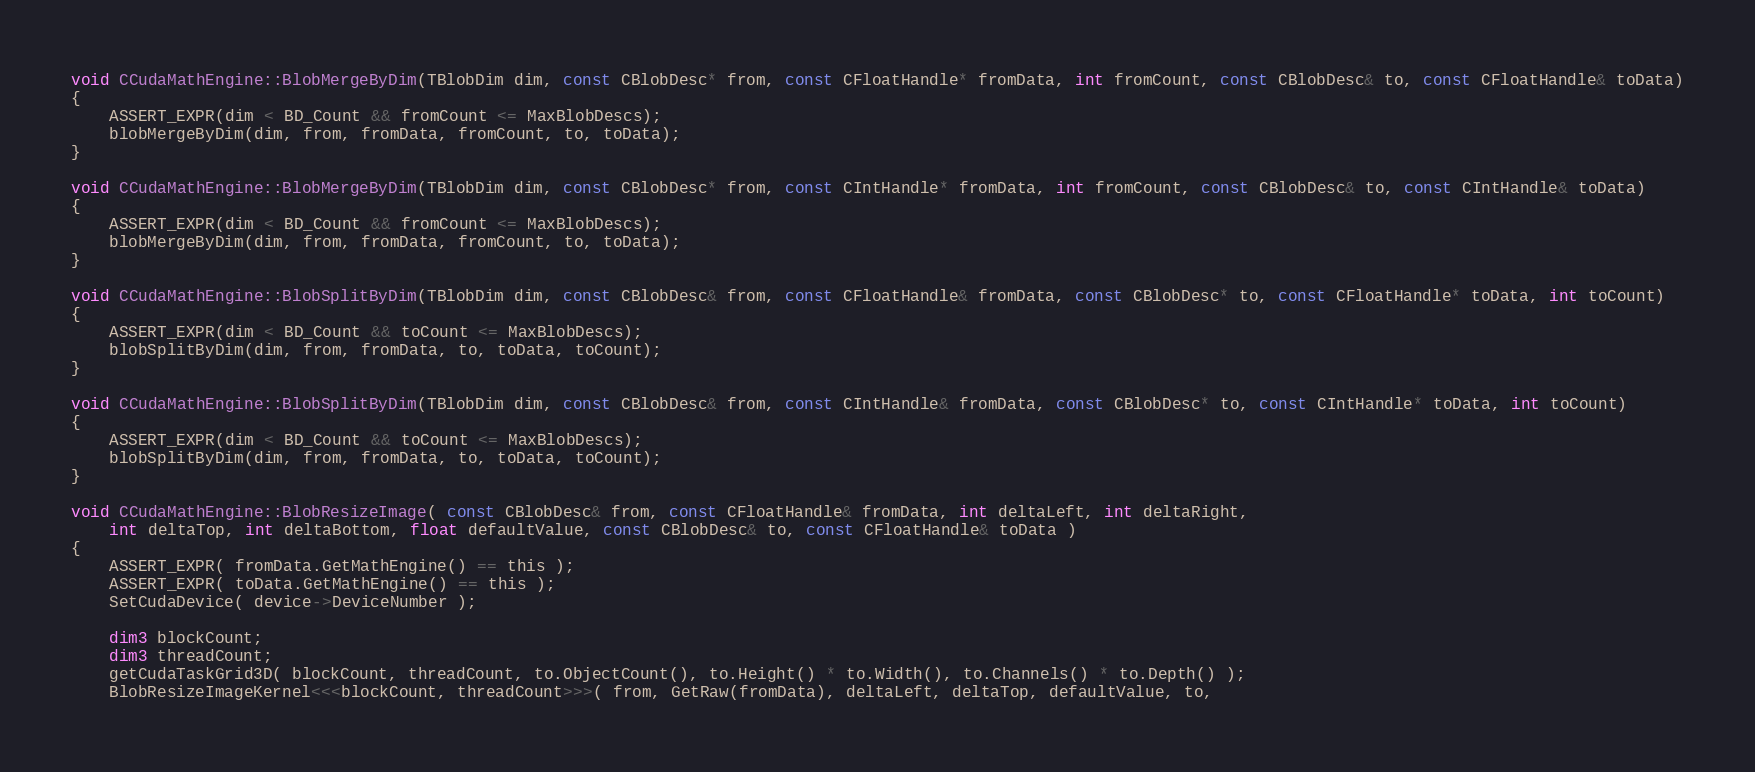Convert code to text. <code><loc_0><loc_0><loc_500><loc_500><_Cuda_>void CCudaMathEngine::BlobMergeByDim(TBlobDim dim, const CBlobDesc* from, const CFloatHandle* fromData, int fromCount, const CBlobDesc& to, const CFloatHandle& toData)
{
	ASSERT_EXPR(dim < BD_Count && fromCount <= MaxBlobDescs);
	blobMergeByDim(dim, from, fromData, fromCount, to, toData);
}

void CCudaMathEngine::BlobMergeByDim(TBlobDim dim, const CBlobDesc* from, const CIntHandle* fromData, int fromCount, const CBlobDesc& to, const CIntHandle& toData)
{
	ASSERT_EXPR(dim < BD_Count && fromCount <= MaxBlobDescs);
	blobMergeByDim(dim, from, fromData, fromCount, to, toData);
}

void CCudaMathEngine::BlobSplitByDim(TBlobDim dim, const CBlobDesc& from, const CFloatHandle& fromData, const CBlobDesc* to, const CFloatHandle* toData, int toCount)
{
	ASSERT_EXPR(dim < BD_Count && toCount <= MaxBlobDescs);
	blobSplitByDim(dim, from, fromData, to, toData, toCount);
}

void CCudaMathEngine::BlobSplitByDim(TBlobDim dim, const CBlobDesc& from, const CIntHandle& fromData, const CBlobDesc* to, const CIntHandle* toData, int toCount)
{
	ASSERT_EXPR(dim < BD_Count && toCount <= MaxBlobDescs);
	blobSplitByDim(dim, from, fromData, to, toData, toCount);
}

void CCudaMathEngine::BlobResizeImage( const CBlobDesc& from, const CFloatHandle& fromData, int deltaLeft, int deltaRight,
	int deltaTop, int deltaBottom, float defaultValue, const CBlobDesc& to, const CFloatHandle& toData )
{
	ASSERT_EXPR( fromData.GetMathEngine() == this );
	ASSERT_EXPR( toData.GetMathEngine() == this );
	SetCudaDevice( device->DeviceNumber );

	dim3 blockCount;
	dim3 threadCount;
	getCudaTaskGrid3D( blockCount, threadCount, to.ObjectCount(), to.Height() * to.Width(), to.Channels() * to.Depth() );
	BlobResizeImageKernel<<<blockCount, threadCount>>>( from, GetRaw(fromData), deltaLeft, deltaTop, defaultValue, to,</code> 